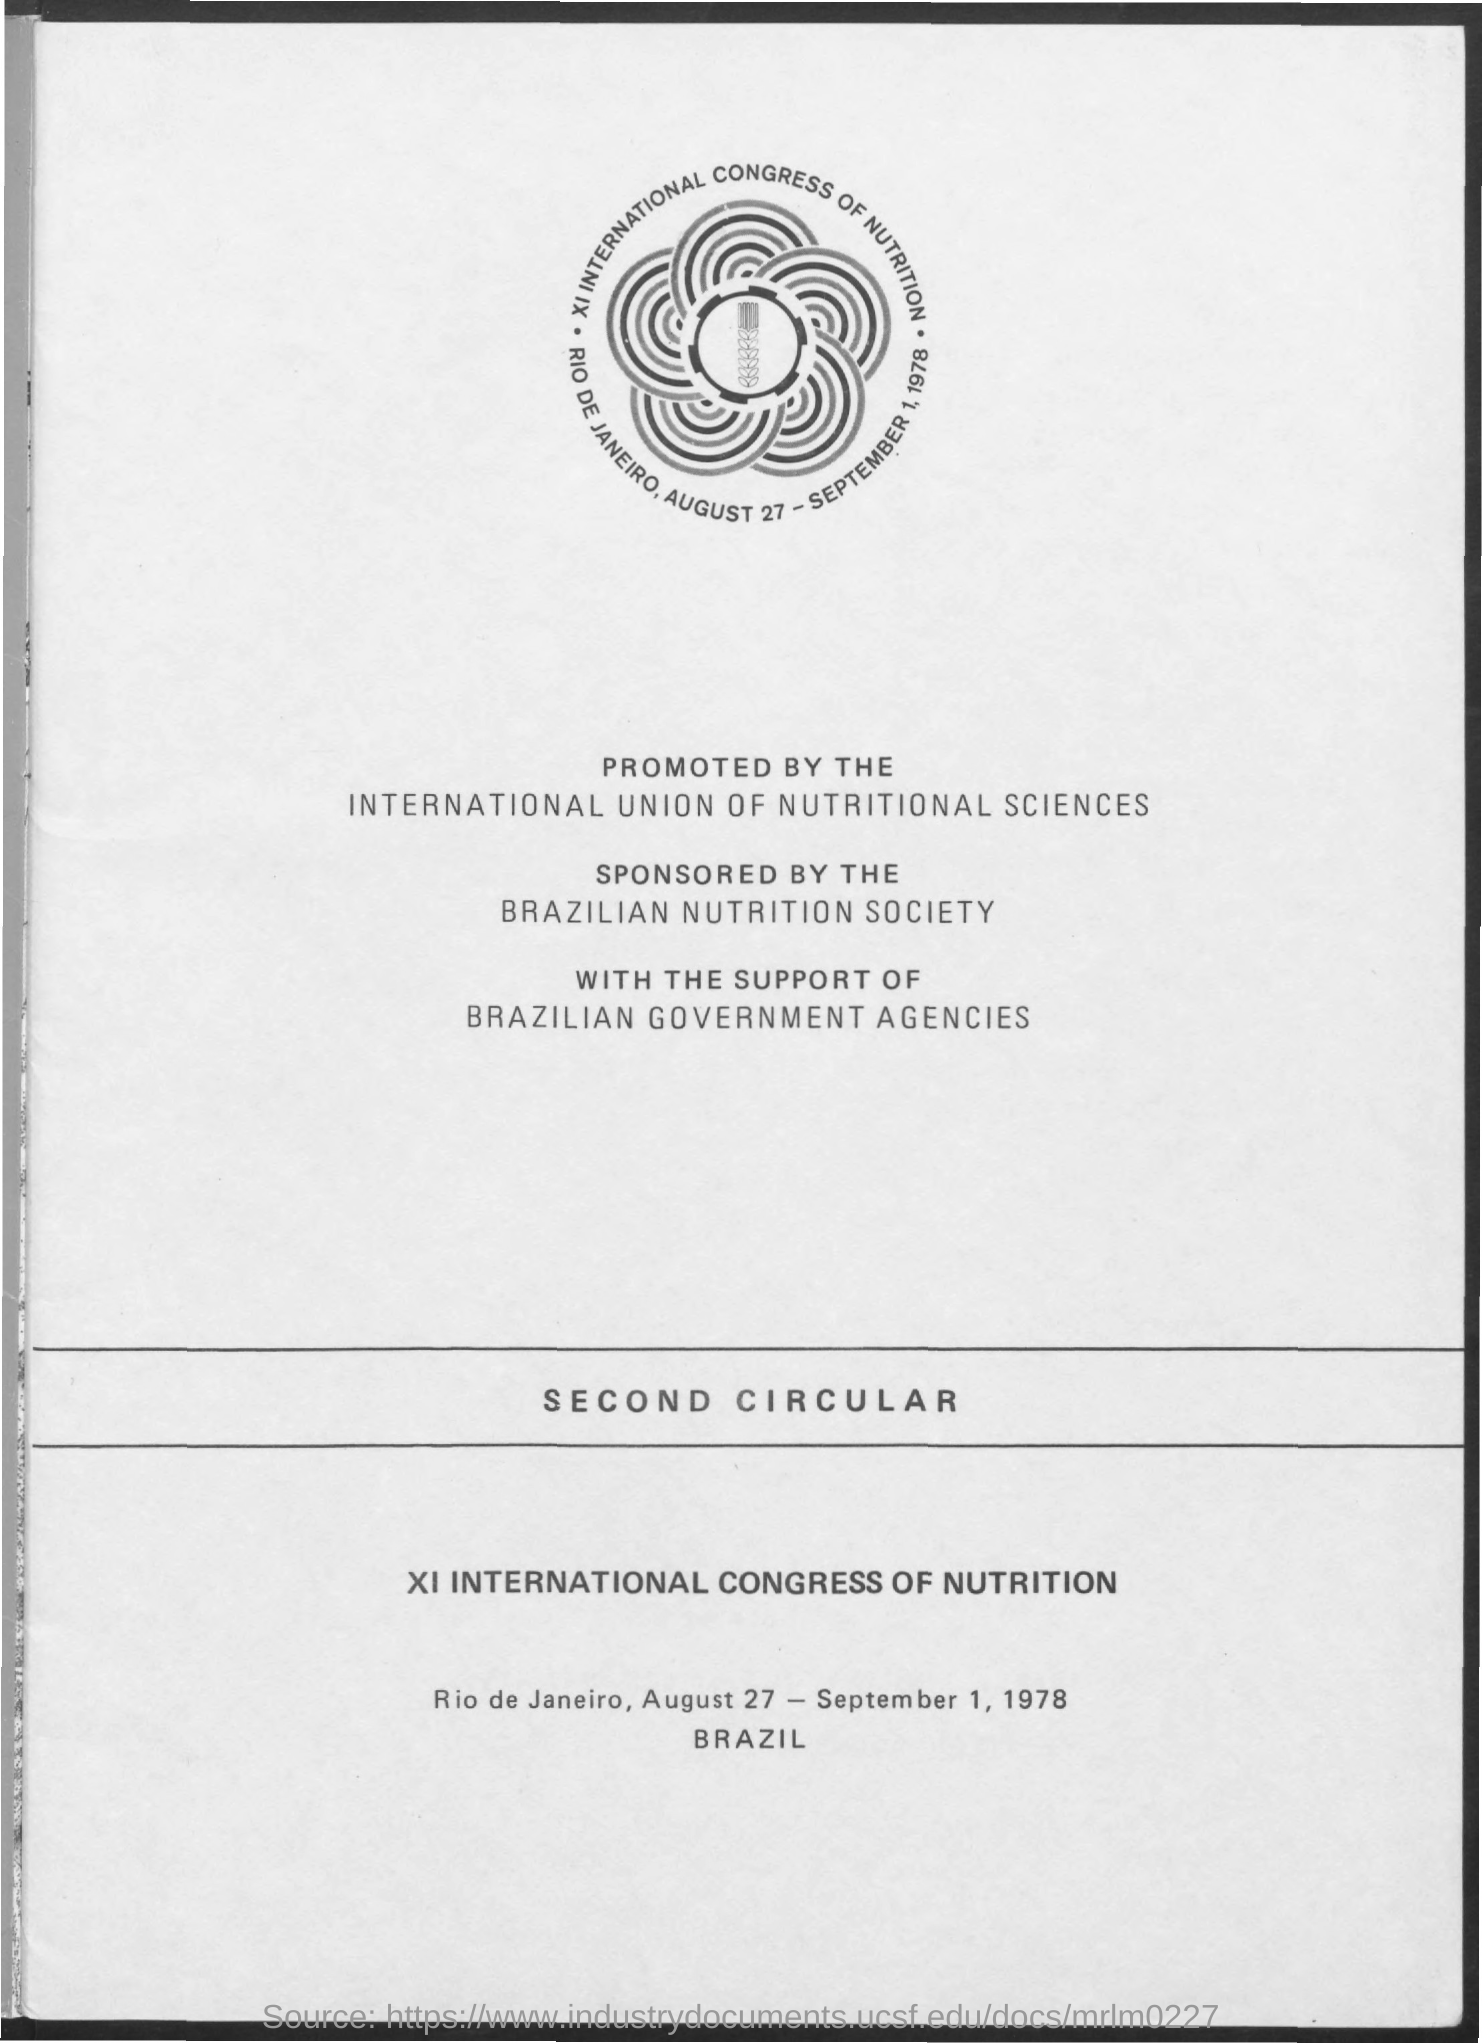Rio de Janeiro is in which country?
Offer a very short reply. Brazil. 